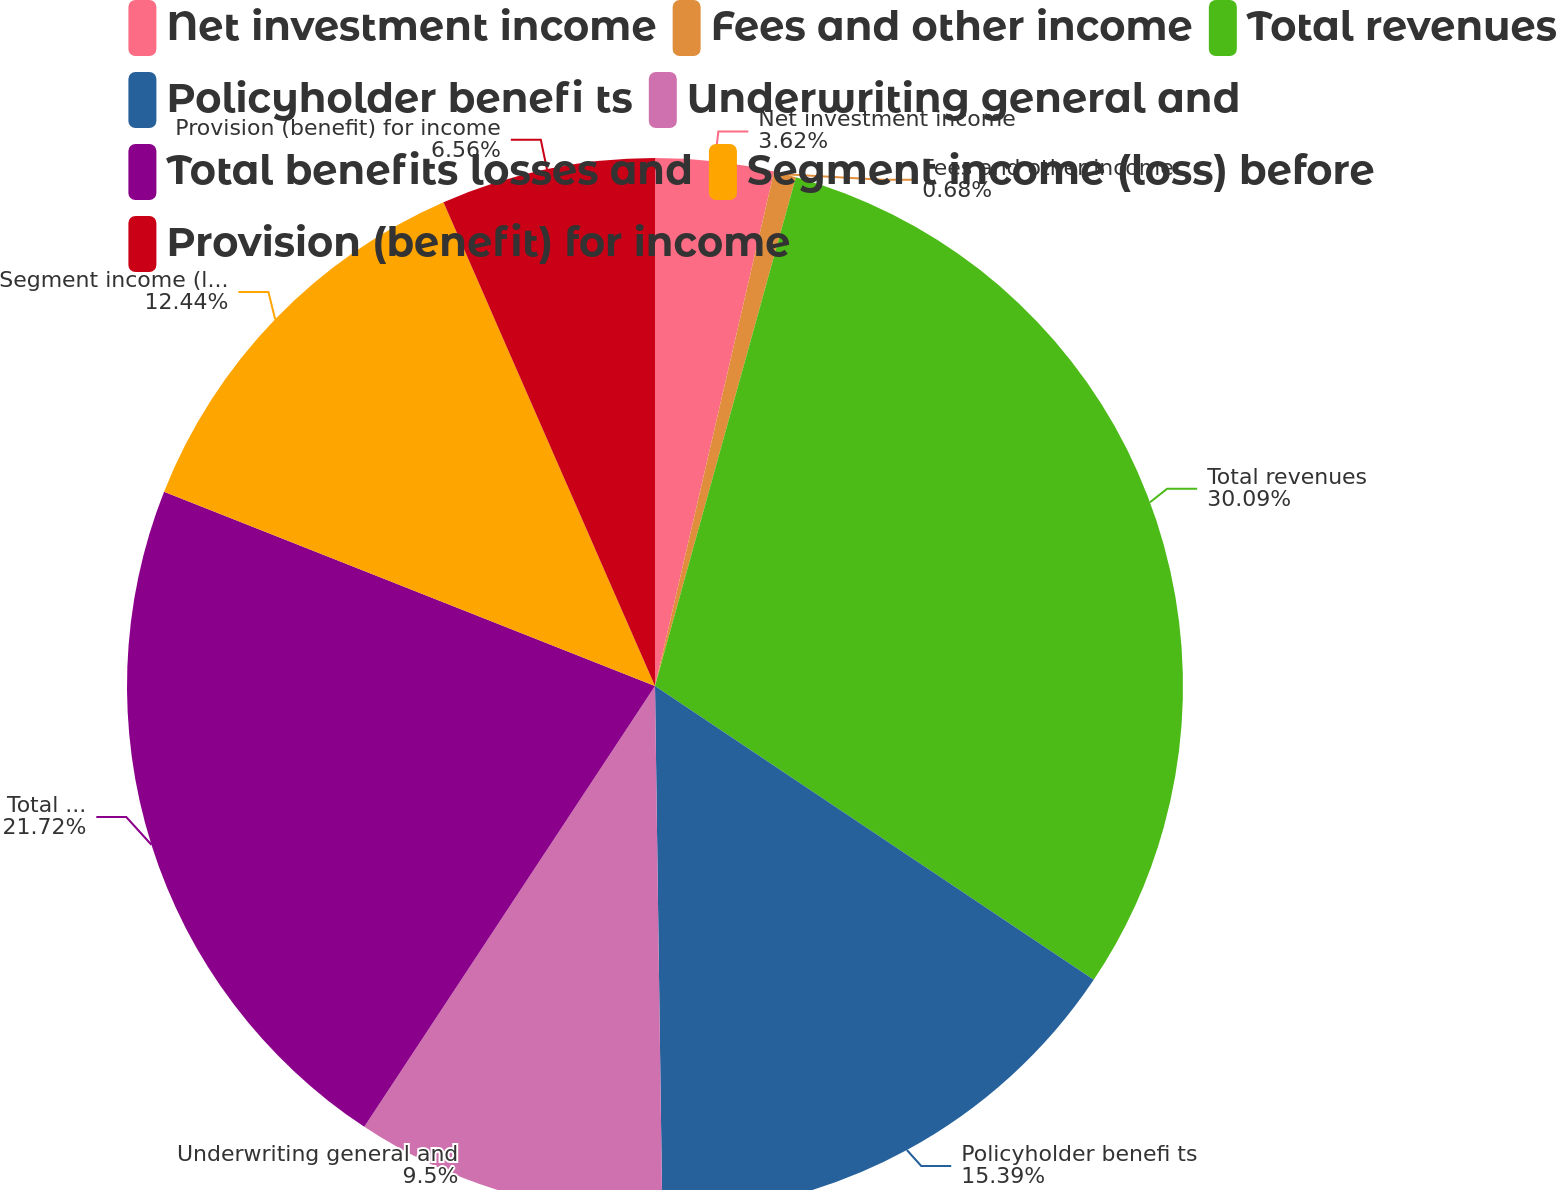Convert chart. <chart><loc_0><loc_0><loc_500><loc_500><pie_chart><fcel>Net investment income<fcel>Fees and other income<fcel>Total revenues<fcel>Policyholder benefi ts<fcel>Underwriting general and<fcel>Total benefits losses and<fcel>Segment income (loss) before<fcel>Provision (benefit) for income<nl><fcel>3.62%<fcel>0.68%<fcel>30.09%<fcel>15.39%<fcel>9.5%<fcel>21.72%<fcel>12.44%<fcel>6.56%<nl></chart> 